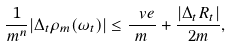<formula> <loc_0><loc_0><loc_500><loc_500>\frac { 1 } { m ^ { n } } | \Delta _ { t } \rho _ { m } ( \omega _ { t } ) | \leq \frac { \ v e } { m } + \frac { | \Delta _ { t } R _ { t } | } { 2 m } ,</formula> 